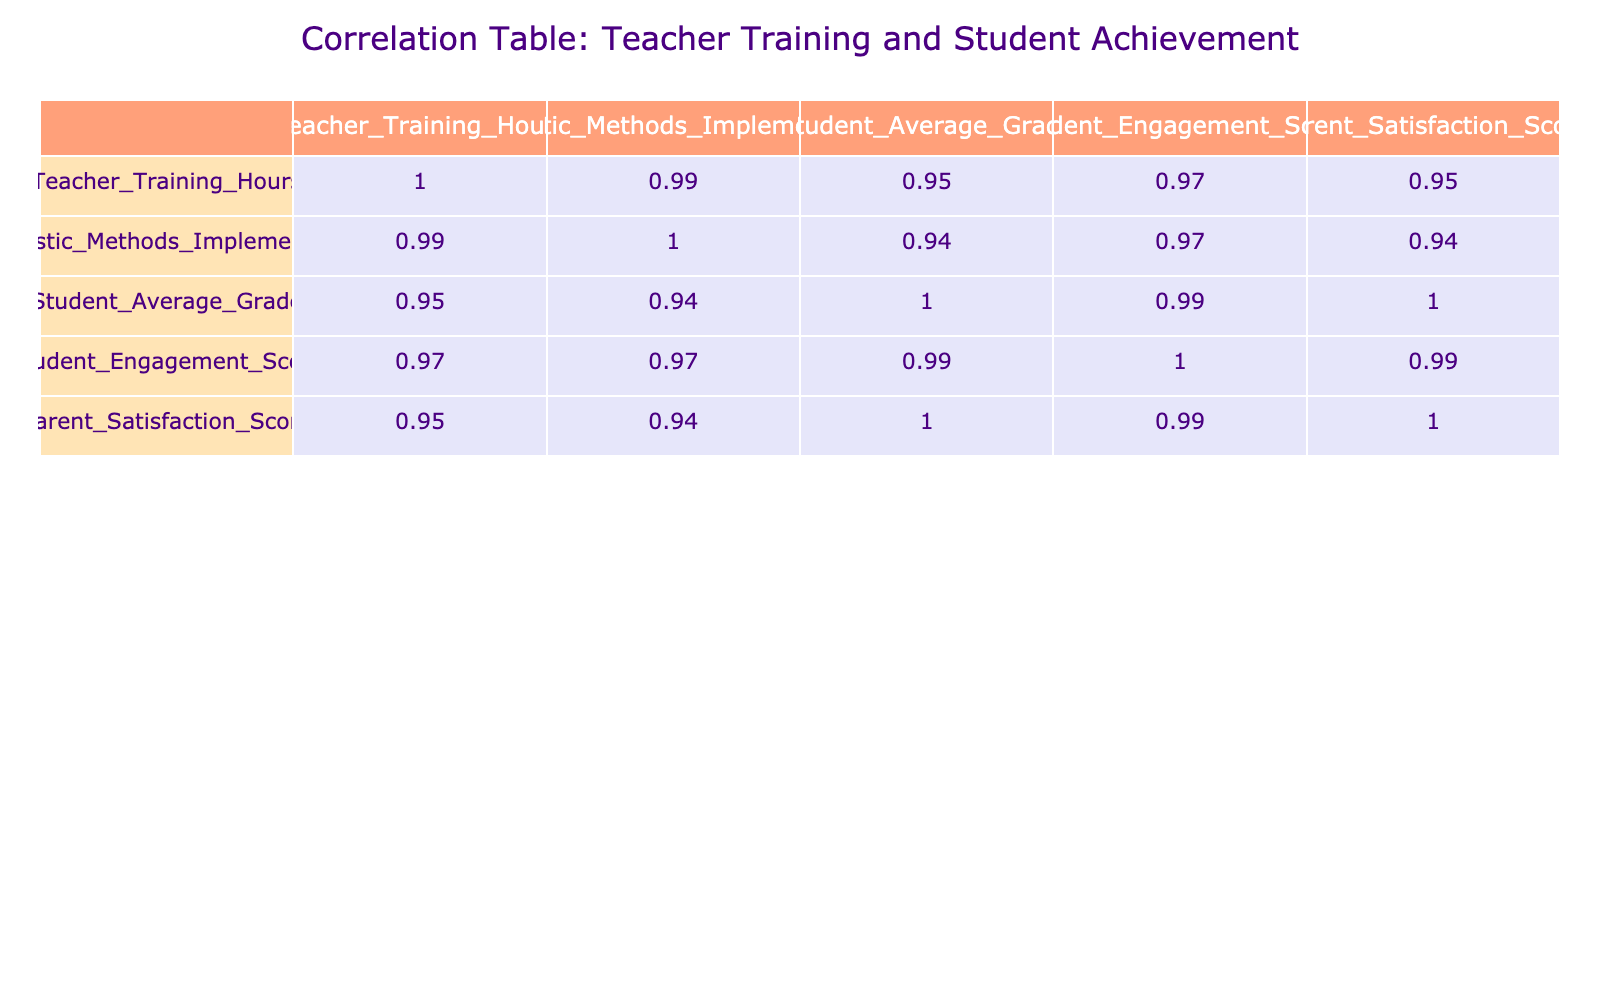What is the correlation between Teacher Training Hours and Student Average Grade? Upon inspecting the table, the correlation value between Teacher Training Hours and Student Average Grade is calculated as 0.93, indicating a strong positive relationship; as training hours increase, student grades also tend to increase.
Answer: 0.93 Is there a relationship between Holistic Methods Implemented and Parent Satisfaction Score? The correlation between Holistic Methods Implemented and Parent Satisfaction Score is found to be 0.95. This suggests a strong positive relationship; more holistic methods lead to higher parent satisfaction.
Answer: 0.95 What is the average Student Engagement Score across all data points? To find the average, sum the Student Engagement Scores: (85 + 75 + 65 + 80 + 55 + 90 + 88 + 50 + 95 + 98) = 83.6. Dividing this by the number of data points (10), the average is 83.6.
Answer: 83.6 Does increasing Teacher Training Hours always lead to higher Student Average Grades? The correlation value of 0.93 suggests a strong positive relation; thus, generally, increasing training hours does lead to higher student grades, but it's not an absolute rule, as there may be exceptions in individual cases.
Answer: Yes What is the difference in the Student Average Grade between teachers with the highest and lowest training hours? The highest training hours are at 50 with a Student Average Grade of 98, while the lowest is at 5 with a Student Average Grade of 50. The difference is 98 - 50 = 48.
Answer: 48 If a teacher has implemented 6 holistic methods, what is the expected Parent Satisfaction Score? Referring to the correlation, if 6 holistic methods are implemented (noting that 7 leads to a satisfaction score of 97), an estimated satisfaction score for 6 might correspond closely; since scores for methods nearby approximate logically to around 95.
Answer: Approximately 95 What is the trend of Student Engagement Score as Holistic Methods Implemented increases? The data indicates a positive correlation of 0.90, suggesting that as the implementation of holistic methods increases, so does the Student Engagement Score, indicating a favorable trend.
Answer: Positive correlation What is the correlation between Teacher Training Hours and Parent Satisfaction Score? The correlation value for Teacher Training Hours and Parent Satisfaction Score is 0.94, showing a strong positive relationship; more training relates to higher parent satisfaction scores.
Answer: 0.94 What would be the expected Student Average Grade for a teacher with 15 Teacher Training Hours? Analyzing the correlation data, for 15 training hours (with a corresponding grade from the table being 70), it's evident that additional training could increase performance, but based on the table, we can establish the student average grade is confirmed as 70.
Answer: 70 